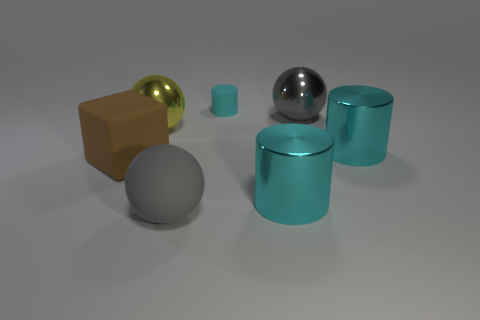What is the shape of the large gray object that is the same material as the large brown thing?
Keep it short and to the point. Sphere. There is a matte object behind the big brown cube; does it have the same shape as the gray matte object?
Give a very brief answer. No. How many yellow objects are either big cylinders or shiny things?
Ensure brevity in your answer.  1. Is the number of gray metallic balls left of the big yellow thing the same as the number of yellow shiny balls on the right side of the big gray matte sphere?
Offer a terse response. Yes. There is a metal sphere left of the big cyan object left of the big metal ball behind the yellow metallic ball; what is its color?
Keep it short and to the point. Yellow. Is there any other thing of the same color as the small rubber thing?
Give a very brief answer. Yes. The shiny object that is the same color as the big rubber ball is what shape?
Your answer should be very brief. Sphere. What size is the gray sphere that is to the right of the small cyan cylinder?
Provide a succinct answer. Large. What is the shape of the other gray thing that is the same size as the gray shiny thing?
Offer a very short reply. Sphere. Is the large gray object behind the yellow ball made of the same material as the brown cube that is in front of the small cyan cylinder?
Offer a very short reply. No. 